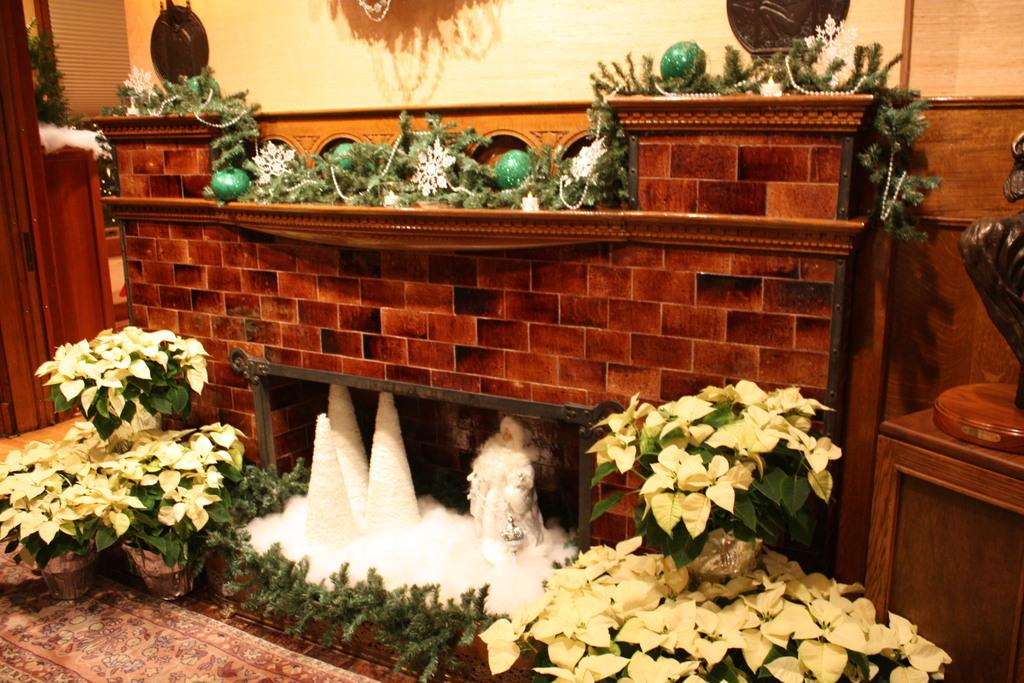What type of living organisms can be seen in the image? Plants can be seen in the image. What objects are also present in the image? There are balls in the image. What is the weather condition in the image? There is snow in the image. What can be seen in the background of the image? There is a wall in the background of the image. What time of day is the class taking place in the image? There is no indication of a class or time of day in the image. 